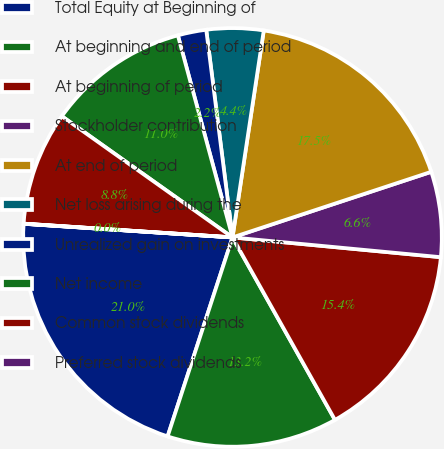<chart> <loc_0><loc_0><loc_500><loc_500><pie_chart><fcel>Total Equity at Beginning of<fcel>At beginning and end of period<fcel>At beginning of period<fcel>Stockholder contribution<fcel>At end of period<fcel>Net loss arising during the<fcel>Unrealized gain on investments<fcel>Net income<fcel>Common stock dividends<fcel>Preferred stock dividends<nl><fcel>21.02%<fcel>13.16%<fcel>15.35%<fcel>6.58%<fcel>17.54%<fcel>4.39%<fcel>2.2%<fcel>10.97%<fcel>8.78%<fcel>0.01%<nl></chart> 